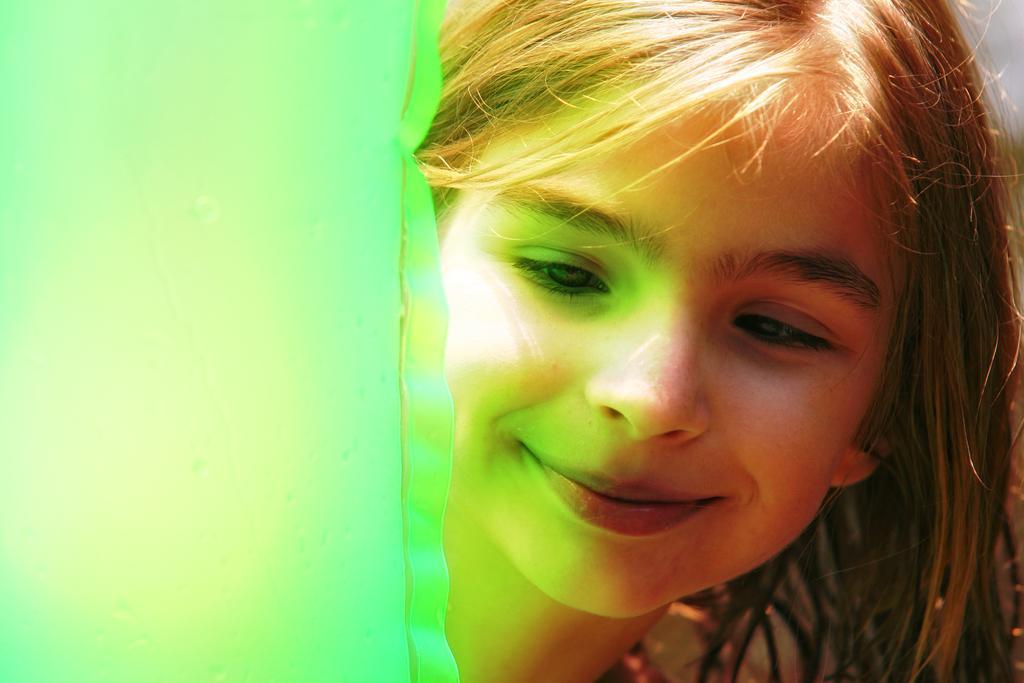In one or two sentences, can you explain what this image depicts? In this image there is a girl with a smile on her face. 